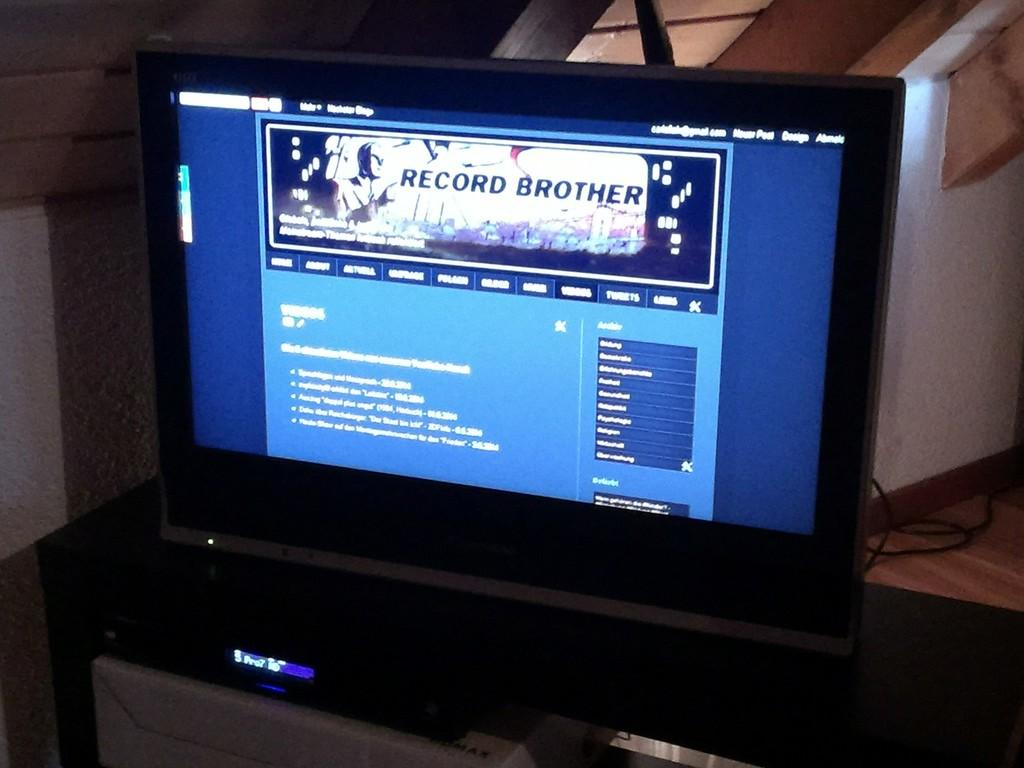<image>
Describe the image concisely. The screen to a television with the text Record Brother on the screen. 